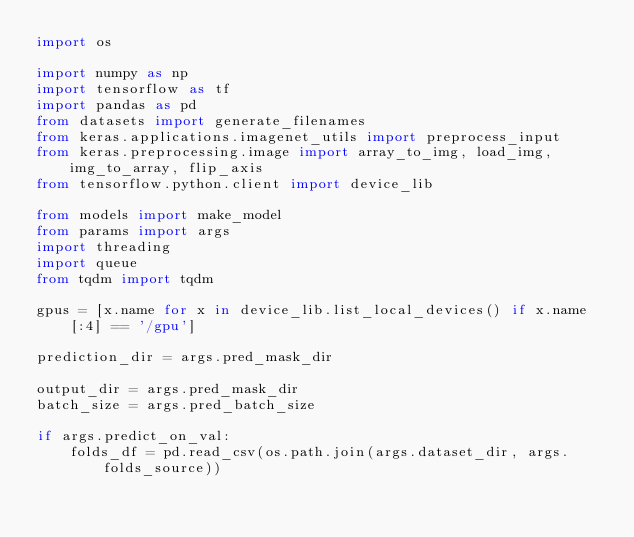<code> <loc_0><loc_0><loc_500><loc_500><_Python_>import os

import numpy as np
import tensorflow as tf
import pandas as pd
from datasets import generate_filenames
from keras.applications.imagenet_utils import preprocess_input
from keras.preprocessing.image import array_to_img, load_img, img_to_array, flip_axis
from tensorflow.python.client import device_lib

from models import make_model
from params import args
import threading
import queue
from tqdm import tqdm

gpus = [x.name for x in device_lib.list_local_devices() if x.name[:4] == '/gpu']

prediction_dir = args.pred_mask_dir

output_dir = args.pred_mask_dir
batch_size = args.pred_batch_size

if args.predict_on_val:
    folds_df = pd.read_csv(os.path.join(args.dataset_dir, args.folds_source))</code> 